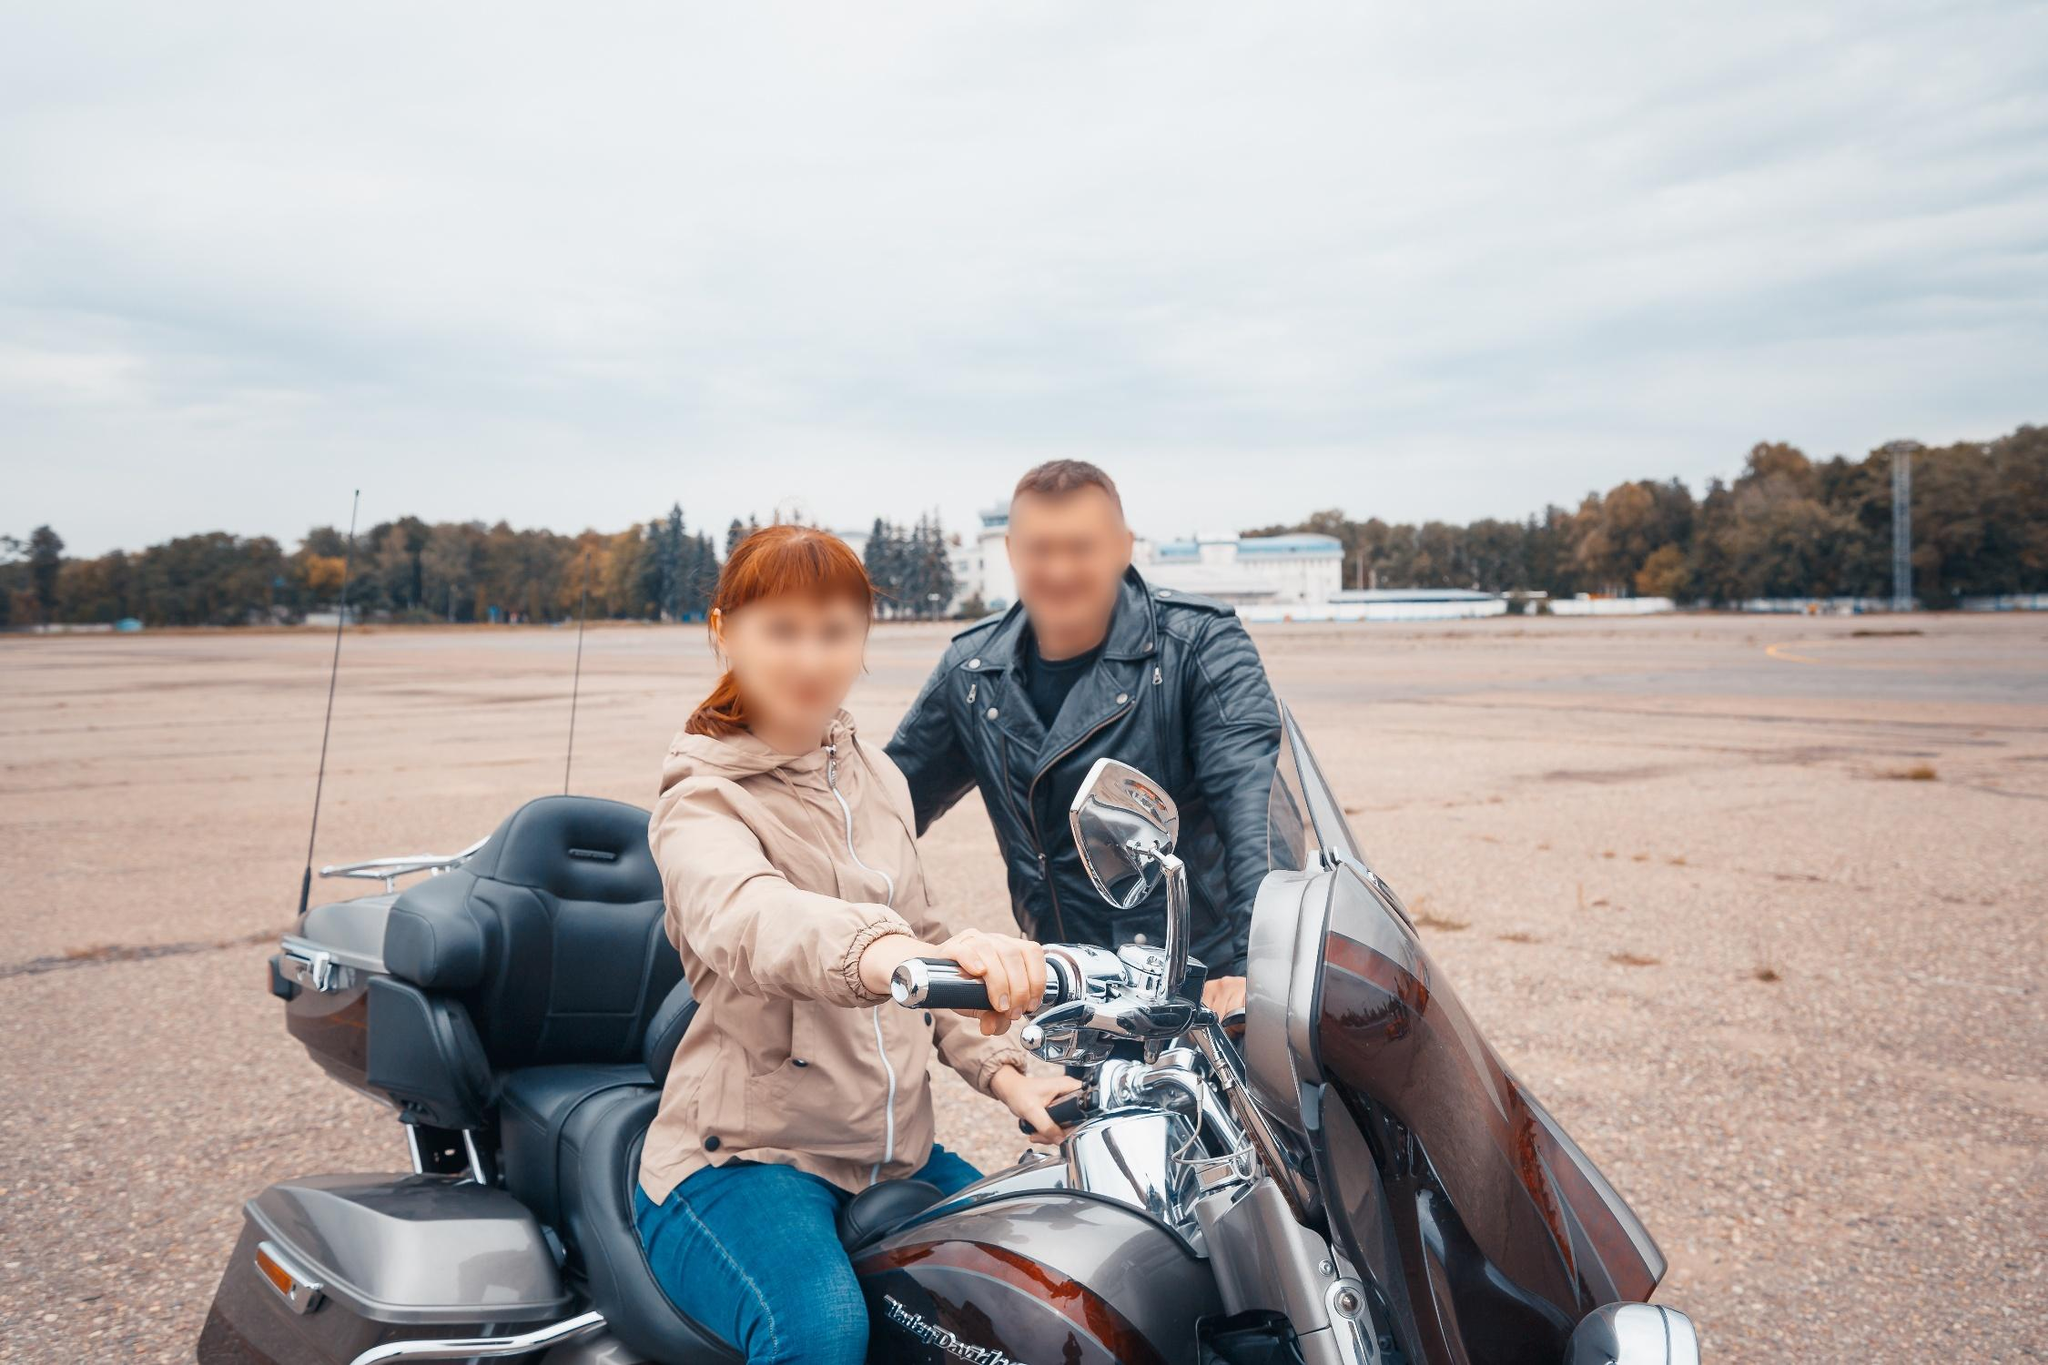Create a very imaginative and fantastical scenario involving the motorcycle and the couple. As the couple rides their Harley Davidson through an enchanted forest, they suddenly stumble upon a hidden portal shimmering in the middle of the road. Without hesitation, they accelerate and ride through, emerging in a fantastical realm where the sky blazes with vivid colors and floating islands dot the horizon. Their motorcycle, now imbued with mystical powers, can fly and traverse through barriers of time and space. They embark on a quest to unite the fragmented kingdoms of this magical land, encountering mythical creatures, and unlocking ancient secrets. Along their journey, they discover their roles as the destined protectors of this realm, with the motorcycle serving as a legendary steed carrying them through their epic adventures. 